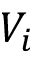<formula> <loc_0><loc_0><loc_500><loc_500>V _ { i }</formula> 